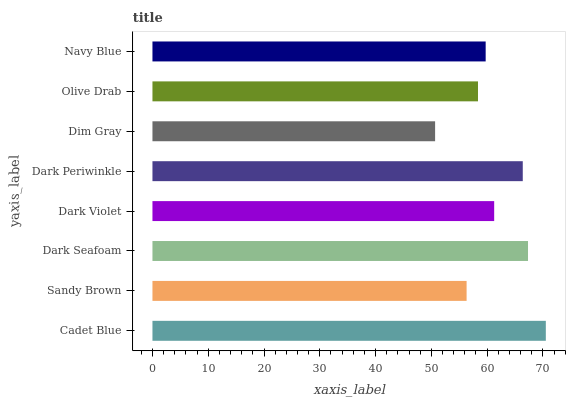Is Dim Gray the minimum?
Answer yes or no. Yes. Is Cadet Blue the maximum?
Answer yes or no. Yes. Is Sandy Brown the minimum?
Answer yes or no. No. Is Sandy Brown the maximum?
Answer yes or no. No. Is Cadet Blue greater than Sandy Brown?
Answer yes or no. Yes. Is Sandy Brown less than Cadet Blue?
Answer yes or no. Yes. Is Sandy Brown greater than Cadet Blue?
Answer yes or no. No. Is Cadet Blue less than Sandy Brown?
Answer yes or no. No. Is Dark Violet the high median?
Answer yes or no. Yes. Is Navy Blue the low median?
Answer yes or no. Yes. Is Dim Gray the high median?
Answer yes or no. No. Is Cadet Blue the low median?
Answer yes or no. No. 